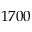Convert formula to latex. <formula><loc_0><loc_0><loc_500><loc_500>1 7 0 0</formula> 